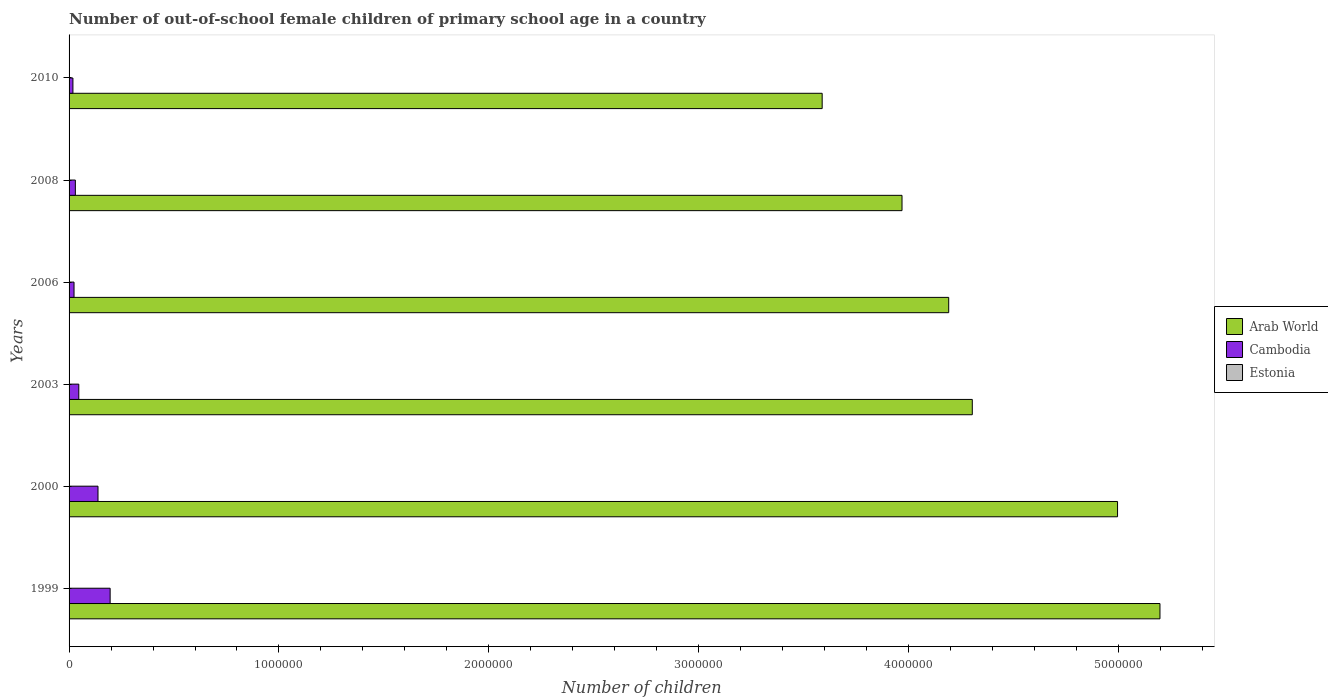How many groups of bars are there?
Your response must be concise. 6. Are the number of bars per tick equal to the number of legend labels?
Offer a terse response. Yes. How many bars are there on the 4th tick from the top?
Offer a terse response. 3. How many bars are there on the 3rd tick from the bottom?
Give a very brief answer. 3. In how many cases, is the number of bars for a given year not equal to the number of legend labels?
Provide a succinct answer. 0. What is the number of out-of-school female children in Arab World in 2008?
Provide a succinct answer. 3.97e+06. Across all years, what is the maximum number of out-of-school female children in Estonia?
Your answer should be very brief. 1186. Across all years, what is the minimum number of out-of-school female children in Arab World?
Provide a succinct answer. 3.59e+06. In which year was the number of out-of-school female children in Estonia maximum?
Make the answer very short. 2003. In which year was the number of out-of-school female children in Arab World minimum?
Your answer should be compact. 2010. What is the total number of out-of-school female children in Cambodia in the graph?
Ensure brevity in your answer.  4.52e+05. What is the difference between the number of out-of-school female children in Cambodia in 2000 and that in 2008?
Offer a terse response. 1.08e+05. What is the difference between the number of out-of-school female children in Cambodia in 2008 and the number of out-of-school female children in Arab World in 2003?
Make the answer very short. -4.27e+06. What is the average number of out-of-school female children in Estonia per year?
Provide a succinct answer. 780.33. In the year 2010, what is the difference between the number of out-of-school female children in Estonia and number of out-of-school female children in Arab World?
Offer a terse response. -3.59e+06. What is the ratio of the number of out-of-school female children in Arab World in 2006 to that in 2008?
Your answer should be compact. 1.06. What is the difference between the highest and the second highest number of out-of-school female children in Arab World?
Provide a short and direct response. 2.02e+05. What is the difference between the highest and the lowest number of out-of-school female children in Arab World?
Ensure brevity in your answer.  1.61e+06. Is the sum of the number of out-of-school female children in Arab World in 1999 and 2008 greater than the maximum number of out-of-school female children in Cambodia across all years?
Offer a very short reply. Yes. What does the 2nd bar from the top in 1999 represents?
Keep it short and to the point. Cambodia. What does the 2nd bar from the bottom in 1999 represents?
Make the answer very short. Cambodia. Is it the case that in every year, the sum of the number of out-of-school female children in Arab World and number of out-of-school female children in Estonia is greater than the number of out-of-school female children in Cambodia?
Ensure brevity in your answer.  Yes. How many bars are there?
Provide a succinct answer. 18. Are all the bars in the graph horizontal?
Your response must be concise. Yes. How many years are there in the graph?
Make the answer very short. 6. What is the difference between two consecutive major ticks on the X-axis?
Provide a short and direct response. 1.00e+06. Are the values on the major ticks of X-axis written in scientific E-notation?
Ensure brevity in your answer.  No. Does the graph contain any zero values?
Provide a succinct answer. No. Does the graph contain grids?
Keep it short and to the point. No. How are the legend labels stacked?
Provide a succinct answer. Vertical. What is the title of the graph?
Give a very brief answer. Number of out-of-school female children of primary school age in a country. What is the label or title of the X-axis?
Offer a very short reply. Number of children. What is the label or title of the Y-axis?
Offer a very short reply. Years. What is the Number of children of Arab World in 1999?
Provide a short and direct response. 5.20e+06. What is the Number of children of Cambodia in 1999?
Keep it short and to the point. 1.96e+05. What is the Number of children of Estonia in 1999?
Offer a terse response. 118. What is the Number of children of Arab World in 2000?
Offer a terse response. 5.00e+06. What is the Number of children of Cambodia in 2000?
Your response must be concise. 1.38e+05. What is the Number of children of Estonia in 2000?
Your answer should be compact. 177. What is the Number of children in Arab World in 2003?
Give a very brief answer. 4.30e+06. What is the Number of children of Cambodia in 2003?
Ensure brevity in your answer.  4.64e+04. What is the Number of children in Estonia in 2003?
Offer a very short reply. 1186. What is the Number of children in Arab World in 2006?
Give a very brief answer. 4.19e+06. What is the Number of children of Cambodia in 2006?
Your answer should be compact. 2.36e+04. What is the Number of children of Estonia in 2006?
Make the answer very short. 1133. What is the Number of children in Arab World in 2008?
Keep it short and to the point. 3.97e+06. What is the Number of children of Cambodia in 2008?
Make the answer very short. 2.99e+04. What is the Number of children in Estonia in 2008?
Your answer should be compact. 1074. What is the Number of children of Arab World in 2010?
Your answer should be compact. 3.59e+06. What is the Number of children in Cambodia in 2010?
Offer a terse response. 1.84e+04. What is the Number of children of Estonia in 2010?
Offer a terse response. 994. Across all years, what is the maximum Number of children in Arab World?
Your response must be concise. 5.20e+06. Across all years, what is the maximum Number of children in Cambodia?
Provide a succinct answer. 1.96e+05. Across all years, what is the maximum Number of children of Estonia?
Keep it short and to the point. 1186. Across all years, what is the minimum Number of children of Arab World?
Ensure brevity in your answer.  3.59e+06. Across all years, what is the minimum Number of children in Cambodia?
Give a very brief answer. 1.84e+04. Across all years, what is the minimum Number of children in Estonia?
Make the answer very short. 118. What is the total Number of children of Arab World in the graph?
Your response must be concise. 2.62e+07. What is the total Number of children of Cambodia in the graph?
Offer a terse response. 4.52e+05. What is the total Number of children in Estonia in the graph?
Provide a succinct answer. 4682. What is the difference between the Number of children in Arab World in 1999 and that in 2000?
Provide a short and direct response. 2.02e+05. What is the difference between the Number of children of Cambodia in 1999 and that in 2000?
Make the answer very short. 5.79e+04. What is the difference between the Number of children in Estonia in 1999 and that in 2000?
Your response must be concise. -59. What is the difference between the Number of children of Arab World in 1999 and that in 2003?
Offer a very short reply. 8.94e+05. What is the difference between the Number of children in Cambodia in 1999 and that in 2003?
Keep it short and to the point. 1.49e+05. What is the difference between the Number of children in Estonia in 1999 and that in 2003?
Offer a terse response. -1068. What is the difference between the Number of children of Arab World in 1999 and that in 2006?
Offer a terse response. 1.01e+06. What is the difference between the Number of children in Cambodia in 1999 and that in 2006?
Offer a terse response. 1.72e+05. What is the difference between the Number of children of Estonia in 1999 and that in 2006?
Provide a short and direct response. -1015. What is the difference between the Number of children in Arab World in 1999 and that in 2008?
Make the answer very short. 1.23e+06. What is the difference between the Number of children in Cambodia in 1999 and that in 2008?
Your response must be concise. 1.66e+05. What is the difference between the Number of children in Estonia in 1999 and that in 2008?
Provide a succinct answer. -956. What is the difference between the Number of children of Arab World in 1999 and that in 2010?
Offer a terse response. 1.61e+06. What is the difference between the Number of children of Cambodia in 1999 and that in 2010?
Provide a succinct answer. 1.77e+05. What is the difference between the Number of children of Estonia in 1999 and that in 2010?
Ensure brevity in your answer.  -876. What is the difference between the Number of children of Arab World in 2000 and that in 2003?
Offer a terse response. 6.92e+05. What is the difference between the Number of children of Cambodia in 2000 and that in 2003?
Offer a very short reply. 9.15e+04. What is the difference between the Number of children in Estonia in 2000 and that in 2003?
Give a very brief answer. -1009. What is the difference between the Number of children in Arab World in 2000 and that in 2006?
Offer a terse response. 8.04e+05. What is the difference between the Number of children in Cambodia in 2000 and that in 2006?
Ensure brevity in your answer.  1.14e+05. What is the difference between the Number of children in Estonia in 2000 and that in 2006?
Offer a terse response. -956. What is the difference between the Number of children of Arab World in 2000 and that in 2008?
Provide a short and direct response. 1.03e+06. What is the difference between the Number of children of Cambodia in 2000 and that in 2008?
Make the answer very short. 1.08e+05. What is the difference between the Number of children in Estonia in 2000 and that in 2008?
Offer a very short reply. -897. What is the difference between the Number of children of Arab World in 2000 and that in 2010?
Provide a succinct answer. 1.41e+06. What is the difference between the Number of children of Cambodia in 2000 and that in 2010?
Offer a terse response. 1.20e+05. What is the difference between the Number of children of Estonia in 2000 and that in 2010?
Provide a succinct answer. -817. What is the difference between the Number of children of Arab World in 2003 and that in 2006?
Keep it short and to the point. 1.12e+05. What is the difference between the Number of children of Cambodia in 2003 and that in 2006?
Your answer should be very brief. 2.27e+04. What is the difference between the Number of children of Arab World in 2003 and that in 2008?
Make the answer very short. 3.35e+05. What is the difference between the Number of children of Cambodia in 2003 and that in 2008?
Provide a short and direct response. 1.64e+04. What is the difference between the Number of children of Estonia in 2003 and that in 2008?
Provide a succinct answer. 112. What is the difference between the Number of children of Arab World in 2003 and that in 2010?
Offer a terse response. 7.15e+05. What is the difference between the Number of children in Cambodia in 2003 and that in 2010?
Make the answer very short. 2.80e+04. What is the difference between the Number of children in Estonia in 2003 and that in 2010?
Ensure brevity in your answer.  192. What is the difference between the Number of children in Arab World in 2006 and that in 2008?
Ensure brevity in your answer.  2.23e+05. What is the difference between the Number of children in Cambodia in 2006 and that in 2008?
Your response must be concise. -6297. What is the difference between the Number of children in Estonia in 2006 and that in 2008?
Give a very brief answer. 59. What is the difference between the Number of children in Arab World in 2006 and that in 2010?
Your answer should be very brief. 6.03e+05. What is the difference between the Number of children in Cambodia in 2006 and that in 2010?
Offer a very short reply. 5295. What is the difference between the Number of children in Estonia in 2006 and that in 2010?
Provide a succinct answer. 139. What is the difference between the Number of children in Arab World in 2008 and that in 2010?
Provide a short and direct response. 3.80e+05. What is the difference between the Number of children in Cambodia in 2008 and that in 2010?
Make the answer very short. 1.16e+04. What is the difference between the Number of children of Estonia in 2008 and that in 2010?
Make the answer very short. 80. What is the difference between the Number of children in Arab World in 1999 and the Number of children in Cambodia in 2000?
Keep it short and to the point. 5.06e+06. What is the difference between the Number of children of Arab World in 1999 and the Number of children of Estonia in 2000?
Keep it short and to the point. 5.20e+06. What is the difference between the Number of children in Cambodia in 1999 and the Number of children in Estonia in 2000?
Provide a succinct answer. 1.96e+05. What is the difference between the Number of children in Arab World in 1999 and the Number of children in Cambodia in 2003?
Your answer should be compact. 5.15e+06. What is the difference between the Number of children of Arab World in 1999 and the Number of children of Estonia in 2003?
Your response must be concise. 5.20e+06. What is the difference between the Number of children of Cambodia in 1999 and the Number of children of Estonia in 2003?
Keep it short and to the point. 1.95e+05. What is the difference between the Number of children of Arab World in 1999 and the Number of children of Cambodia in 2006?
Your response must be concise. 5.17e+06. What is the difference between the Number of children in Arab World in 1999 and the Number of children in Estonia in 2006?
Your answer should be compact. 5.20e+06. What is the difference between the Number of children in Cambodia in 1999 and the Number of children in Estonia in 2006?
Your answer should be compact. 1.95e+05. What is the difference between the Number of children in Arab World in 1999 and the Number of children in Cambodia in 2008?
Your answer should be compact. 5.17e+06. What is the difference between the Number of children in Arab World in 1999 and the Number of children in Estonia in 2008?
Offer a terse response. 5.20e+06. What is the difference between the Number of children of Cambodia in 1999 and the Number of children of Estonia in 2008?
Make the answer very short. 1.95e+05. What is the difference between the Number of children in Arab World in 1999 and the Number of children in Cambodia in 2010?
Give a very brief answer. 5.18e+06. What is the difference between the Number of children in Arab World in 1999 and the Number of children in Estonia in 2010?
Give a very brief answer. 5.20e+06. What is the difference between the Number of children of Cambodia in 1999 and the Number of children of Estonia in 2010?
Offer a very short reply. 1.95e+05. What is the difference between the Number of children in Arab World in 2000 and the Number of children in Cambodia in 2003?
Offer a terse response. 4.95e+06. What is the difference between the Number of children of Arab World in 2000 and the Number of children of Estonia in 2003?
Provide a short and direct response. 4.99e+06. What is the difference between the Number of children in Cambodia in 2000 and the Number of children in Estonia in 2003?
Your response must be concise. 1.37e+05. What is the difference between the Number of children in Arab World in 2000 and the Number of children in Cambodia in 2006?
Ensure brevity in your answer.  4.97e+06. What is the difference between the Number of children of Arab World in 2000 and the Number of children of Estonia in 2006?
Your answer should be very brief. 4.99e+06. What is the difference between the Number of children in Cambodia in 2000 and the Number of children in Estonia in 2006?
Provide a succinct answer. 1.37e+05. What is the difference between the Number of children of Arab World in 2000 and the Number of children of Cambodia in 2008?
Give a very brief answer. 4.97e+06. What is the difference between the Number of children of Arab World in 2000 and the Number of children of Estonia in 2008?
Offer a very short reply. 4.99e+06. What is the difference between the Number of children of Cambodia in 2000 and the Number of children of Estonia in 2008?
Offer a very short reply. 1.37e+05. What is the difference between the Number of children of Arab World in 2000 and the Number of children of Cambodia in 2010?
Provide a succinct answer. 4.98e+06. What is the difference between the Number of children in Arab World in 2000 and the Number of children in Estonia in 2010?
Provide a short and direct response. 4.99e+06. What is the difference between the Number of children in Cambodia in 2000 and the Number of children in Estonia in 2010?
Offer a very short reply. 1.37e+05. What is the difference between the Number of children of Arab World in 2003 and the Number of children of Cambodia in 2006?
Keep it short and to the point. 4.28e+06. What is the difference between the Number of children of Arab World in 2003 and the Number of children of Estonia in 2006?
Provide a succinct answer. 4.30e+06. What is the difference between the Number of children of Cambodia in 2003 and the Number of children of Estonia in 2006?
Offer a terse response. 4.52e+04. What is the difference between the Number of children of Arab World in 2003 and the Number of children of Cambodia in 2008?
Your answer should be very brief. 4.27e+06. What is the difference between the Number of children in Arab World in 2003 and the Number of children in Estonia in 2008?
Your answer should be compact. 4.30e+06. What is the difference between the Number of children in Cambodia in 2003 and the Number of children in Estonia in 2008?
Make the answer very short. 4.53e+04. What is the difference between the Number of children of Arab World in 2003 and the Number of children of Cambodia in 2010?
Provide a succinct answer. 4.29e+06. What is the difference between the Number of children of Arab World in 2003 and the Number of children of Estonia in 2010?
Keep it short and to the point. 4.30e+06. What is the difference between the Number of children of Cambodia in 2003 and the Number of children of Estonia in 2010?
Your answer should be very brief. 4.54e+04. What is the difference between the Number of children in Arab World in 2006 and the Number of children in Cambodia in 2008?
Give a very brief answer. 4.16e+06. What is the difference between the Number of children of Arab World in 2006 and the Number of children of Estonia in 2008?
Your response must be concise. 4.19e+06. What is the difference between the Number of children in Cambodia in 2006 and the Number of children in Estonia in 2008?
Offer a terse response. 2.26e+04. What is the difference between the Number of children in Arab World in 2006 and the Number of children in Cambodia in 2010?
Offer a terse response. 4.17e+06. What is the difference between the Number of children in Arab World in 2006 and the Number of children in Estonia in 2010?
Your response must be concise. 4.19e+06. What is the difference between the Number of children of Cambodia in 2006 and the Number of children of Estonia in 2010?
Your answer should be compact. 2.27e+04. What is the difference between the Number of children in Arab World in 2008 and the Number of children in Cambodia in 2010?
Offer a very short reply. 3.95e+06. What is the difference between the Number of children of Arab World in 2008 and the Number of children of Estonia in 2010?
Keep it short and to the point. 3.97e+06. What is the difference between the Number of children in Cambodia in 2008 and the Number of children in Estonia in 2010?
Offer a terse response. 2.89e+04. What is the average Number of children of Arab World per year?
Make the answer very short. 4.37e+06. What is the average Number of children of Cambodia per year?
Offer a very short reply. 7.53e+04. What is the average Number of children in Estonia per year?
Your answer should be very brief. 780.33. In the year 1999, what is the difference between the Number of children of Arab World and Number of children of Cambodia?
Offer a terse response. 5.00e+06. In the year 1999, what is the difference between the Number of children of Arab World and Number of children of Estonia?
Your response must be concise. 5.20e+06. In the year 1999, what is the difference between the Number of children in Cambodia and Number of children in Estonia?
Offer a very short reply. 1.96e+05. In the year 2000, what is the difference between the Number of children of Arab World and Number of children of Cambodia?
Provide a short and direct response. 4.86e+06. In the year 2000, what is the difference between the Number of children in Arab World and Number of children in Estonia?
Offer a terse response. 5.00e+06. In the year 2000, what is the difference between the Number of children in Cambodia and Number of children in Estonia?
Offer a very short reply. 1.38e+05. In the year 2003, what is the difference between the Number of children in Arab World and Number of children in Cambodia?
Keep it short and to the point. 4.26e+06. In the year 2003, what is the difference between the Number of children of Arab World and Number of children of Estonia?
Provide a short and direct response. 4.30e+06. In the year 2003, what is the difference between the Number of children in Cambodia and Number of children in Estonia?
Make the answer very short. 4.52e+04. In the year 2006, what is the difference between the Number of children of Arab World and Number of children of Cambodia?
Provide a succinct answer. 4.17e+06. In the year 2006, what is the difference between the Number of children in Arab World and Number of children in Estonia?
Make the answer very short. 4.19e+06. In the year 2006, what is the difference between the Number of children in Cambodia and Number of children in Estonia?
Your response must be concise. 2.25e+04. In the year 2008, what is the difference between the Number of children of Arab World and Number of children of Cambodia?
Your answer should be compact. 3.94e+06. In the year 2008, what is the difference between the Number of children of Arab World and Number of children of Estonia?
Provide a short and direct response. 3.97e+06. In the year 2008, what is the difference between the Number of children of Cambodia and Number of children of Estonia?
Offer a very short reply. 2.89e+04. In the year 2010, what is the difference between the Number of children in Arab World and Number of children in Cambodia?
Your response must be concise. 3.57e+06. In the year 2010, what is the difference between the Number of children in Arab World and Number of children in Estonia?
Your response must be concise. 3.59e+06. In the year 2010, what is the difference between the Number of children of Cambodia and Number of children of Estonia?
Ensure brevity in your answer.  1.74e+04. What is the ratio of the Number of children in Arab World in 1999 to that in 2000?
Give a very brief answer. 1.04. What is the ratio of the Number of children of Cambodia in 1999 to that in 2000?
Provide a succinct answer. 1.42. What is the ratio of the Number of children in Arab World in 1999 to that in 2003?
Offer a terse response. 1.21. What is the ratio of the Number of children in Cambodia in 1999 to that in 2003?
Your answer should be very brief. 4.22. What is the ratio of the Number of children in Estonia in 1999 to that in 2003?
Ensure brevity in your answer.  0.1. What is the ratio of the Number of children in Arab World in 1999 to that in 2006?
Make the answer very short. 1.24. What is the ratio of the Number of children of Cambodia in 1999 to that in 2006?
Your response must be concise. 8.28. What is the ratio of the Number of children in Estonia in 1999 to that in 2006?
Offer a very short reply. 0.1. What is the ratio of the Number of children of Arab World in 1999 to that in 2008?
Give a very brief answer. 1.31. What is the ratio of the Number of children of Cambodia in 1999 to that in 2008?
Your answer should be compact. 6.54. What is the ratio of the Number of children of Estonia in 1999 to that in 2008?
Your answer should be very brief. 0.11. What is the ratio of the Number of children of Arab World in 1999 to that in 2010?
Provide a short and direct response. 1.45. What is the ratio of the Number of children of Cambodia in 1999 to that in 2010?
Your response must be concise. 10.67. What is the ratio of the Number of children in Estonia in 1999 to that in 2010?
Ensure brevity in your answer.  0.12. What is the ratio of the Number of children in Arab World in 2000 to that in 2003?
Your answer should be compact. 1.16. What is the ratio of the Number of children in Cambodia in 2000 to that in 2003?
Give a very brief answer. 2.97. What is the ratio of the Number of children in Estonia in 2000 to that in 2003?
Provide a short and direct response. 0.15. What is the ratio of the Number of children of Arab World in 2000 to that in 2006?
Your response must be concise. 1.19. What is the ratio of the Number of children in Cambodia in 2000 to that in 2006?
Your answer should be very brief. 5.83. What is the ratio of the Number of children in Estonia in 2000 to that in 2006?
Offer a very short reply. 0.16. What is the ratio of the Number of children in Arab World in 2000 to that in 2008?
Ensure brevity in your answer.  1.26. What is the ratio of the Number of children of Cambodia in 2000 to that in 2008?
Provide a short and direct response. 4.6. What is the ratio of the Number of children of Estonia in 2000 to that in 2008?
Provide a succinct answer. 0.16. What is the ratio of the Number of children in Arab World in 2000 to that in 2010?
Ensure brevity in your answer.  1.39. What is the ratio of the Number of children in Cambodia in 2000 to that in 2010?
Provide a succinct answer. 7.51. What is the ratio of the Number of children in Estonia in 2000 to that in 2010?
Offer a terse response. 0.18. What is the ratio of the Number of children in Arab World in 2003 to that in 2006?
Your answer should be compact. 1.03. What is the ratio of the Number of children in Cambodia in 2003 to that in 2006?
Make the answer very short. 1.96. What is the ratio of the Number of children of Estonia in 2003 to that in 2006?
Your response must be concise. 1.05. What is the ratio of the Number of children of Arab World in 2003 to that in 2008?
Ensure brevity in your answer.  1.08. What is the ratio of the Number of children of Cambodia in 2003 to that in 2008?
Provide a succinct answer. 1.55. What is the ratio of the Number of children of Estonia in 2003 to that in 2008?
Your answer should be very brief. 1.1. What is the ratio of the Number of children in Arab World in 2003 to that in 2010?
Your answer should be very brief. 1.2. What is the ratio of the Number of children in Cambodia in 2003 to that in 2010?
Your answer should be very brief. 2.53. What is the ratio of the Number of children of Estonia in 2003 to that in 2010?
Your answer should be very brief. 1.19. What is the ratio of the Number of children in Arab World in 2006 to that in 2008?
Ensure brevity in your answer.  1.06. What is the ratio of the Number of children in Cambodia in 2006 to that in 2008?
Your answer should be very brief. 0.79. What is the ratio of the Number of children in Estonia in 2006 to that in 2008?
Ensure brevity in your answer.  1.05. What is the ratio of the Number of children in Arab World in 2006 to that in 2010?
Your response must be concise. 1.17. What is the ratio of the Number of children of Cambodia in 2006 to that in 2010?
Your answer should be compact. 1.29. What is the ratio of the Number of children in Estonia in 2006 to that in 2010?
Provide a short and direct response. 1.14. What is the ratio of the Number of children in Arab World in 2008 to that in 2010?
Provide a short and direct response. 1.11. What is the ratio of the Number of children of Cambodia in 2008 to that in 2010?
Offer a very short reply. 1.63. What is the ratio of the Number of children in Estonia in 2008 to that in 2010?
Give a very brief answer. 1.08. What is the difference between the highest and the second highest Number of children in Arab World?
Provide a succinct answer. 2.02e+05. What is the difference between the highest and the second highest Number of children of Cambodia?
Your response must be concise. 5.79e+04. What is the difference between the highest and the lowest Number of children in Arab World?
Your response must be concise. 1.61e+06. What is the difference between the highest and the lowest Number of children in Cambodia?
Provide a short and direct response. 1.77e+05. What is the difference between the highest and the lowest Number of children in Estonia?
Your response must be concise. 1068. 